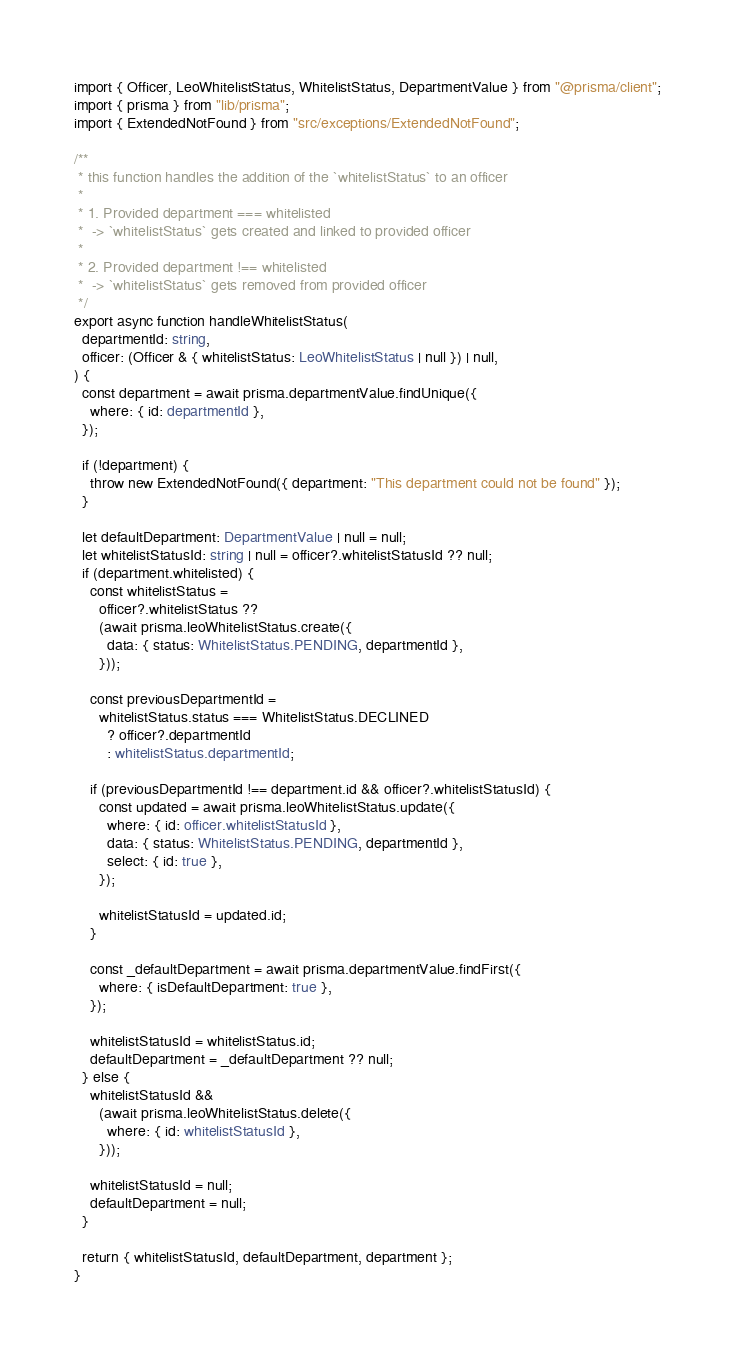<code> <loc_0><loc_0><loc_500><loc_500><_TypeScript_>import { Officer, LeoWhitelistStatus, WhitelistStatus, DepartmentValue } from "@prisma/client";
import { prisma } from "lib/prisma";
import { ExtendedNotFound } from "src/exceptions/ExtendedNotFound";

/**
 * this function handles the addition of the `whitelistStatus` to an officer
 *
 * 1. Provided department === whitelisted
 *  -> `whitelistStatus` gets created and linked to provided officer
 *
 * 2. Provided department !== whitelisted
 *  -> `whitelistStatus` gets removed from provided officer
 */
export async function handleWhitelistStatus(
  departmentId: string,
  officer: (Officer & { whitelistStatus: LeoWhitelistStatus | null }) | null,
) {
  const department = await prisma.departmentValue.findUnique({
    where: { id: departmentId },
  });

  if (!department) {
    throw new ExtendedNotFound({ department: "This department could not be found" });
  }

  let defaultDepartment: DepartmentValue | null = null;
  let whitelistStatusId: string | null = officer?.whitelistStatusId ?? null;
  if (department.whitelisted) {
    const whitelistStatus =
      officer?.whitelistStatus ??
      (await prisma.leoWhitelistStatus.create({
        data: { status: WhitelistStatus.PENDING, departmentId },
      }));

    const previousDepartmentId =
      whitelistStatus.status === WhitelistStatus.DECLINED
        ? officer?.departmentId
        : whitelistStatus.departmentId;

    if (previousDepartmentId !== department.id && officer?.whitelistStatusId) {
      const updated = await prisma.leoWhitelistStatus.update({
        where: { id: officer.whitelistStatusId },
        data: { status: WhitelistStatus.PENDING, departmentId },
        select: { id: true },
      });

      whitelistStatusId = updated.id;
    }

    const _defaultDepartment = await prisma.departmentValue.findFirst({
      where: { isDefaultDepartment: true },
    });

    whitelistStatusId = whitelistStatus.id;
    defaultDepartment = _defaultDepartment ?? null;
  } else {
    whitelistStatusId &&
      (await prisma.leoWhitelistStatus.delete({
        where: { id: whitelistStatusId },
      }));

    whitelistStatusId = null;
    defaultDepartment = null;
  }

  return { whitelistStatusId, defaultDepartment, department };
}
</code> 